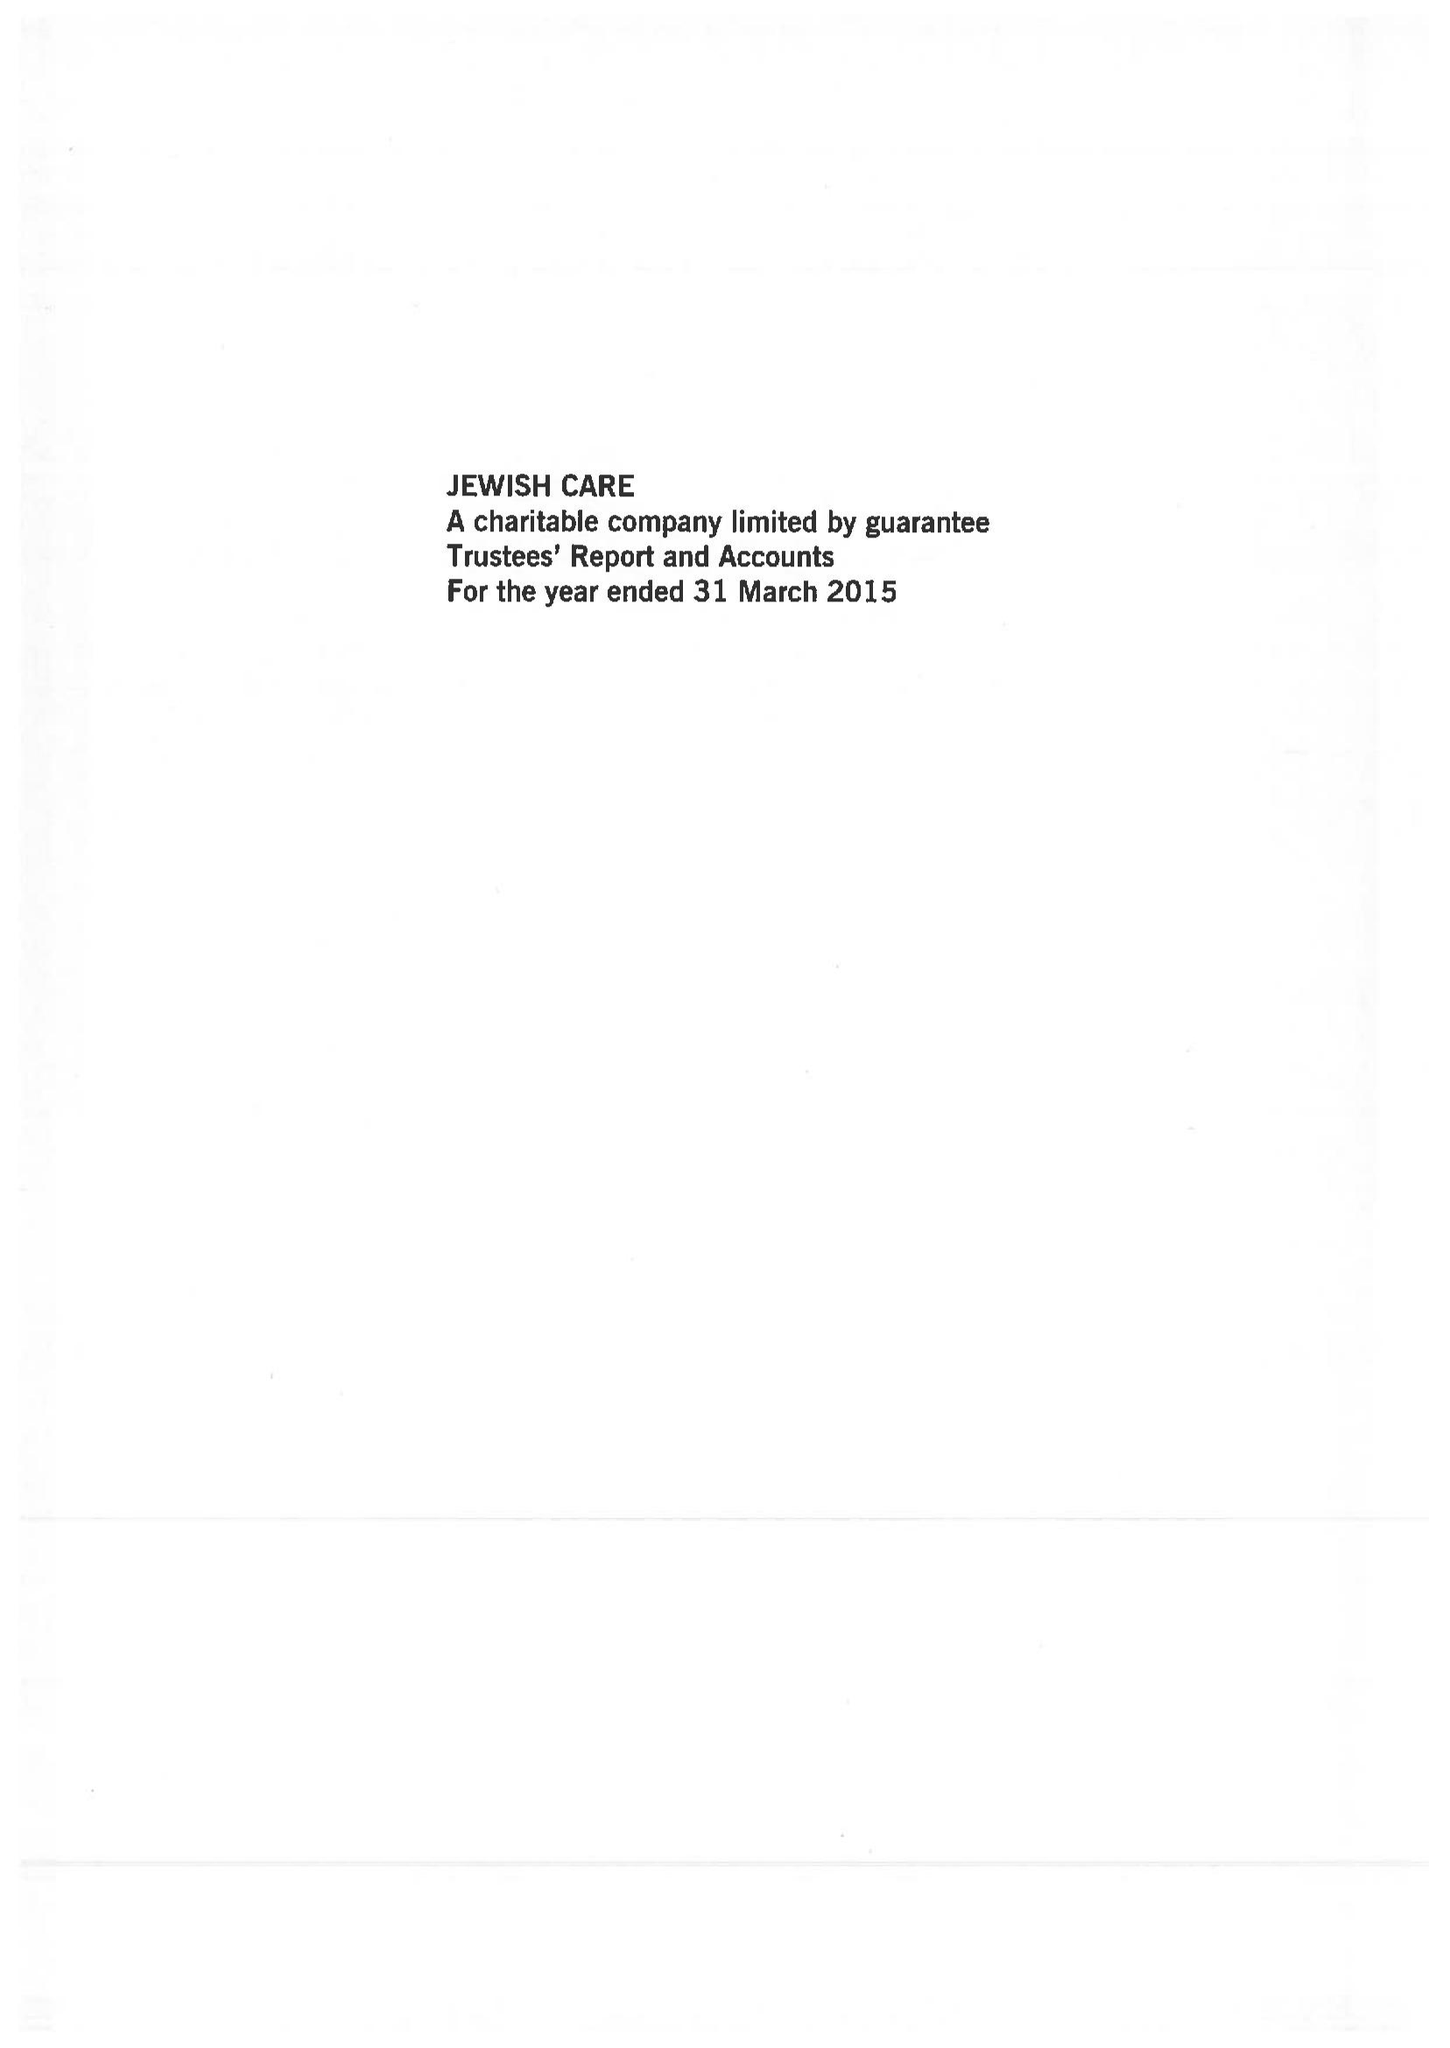What is the value for the income_annually_in_british_pounds?
Answer the question using a single word or phrase. 50976000.00 